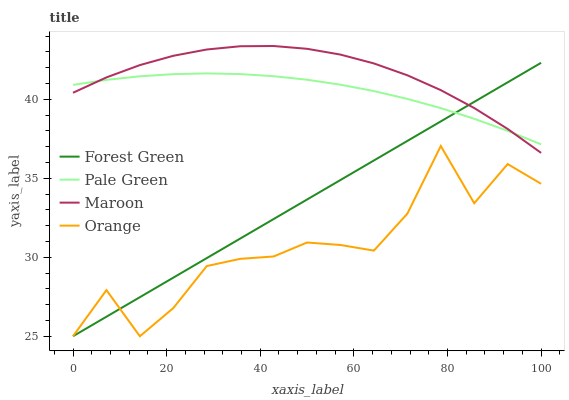Does Orange have the minimum area under the curve?
Answer yes or no. Yes. Does Maroon have the maximum area under the curve?
Answer yes or no. Yes. Does Forest Green have the minimum area under the curve?
Answer yes or no. No. Does Forest Green have the maximum area under the curve?
Answer yes or no. No. Is Forest Green the smoothest?
Answer yes or no. Yes. Is Orange the roughest?
Answer yes or no. Yes. Is Pale Green the smoothest?
Answer yes or no. No. Is Pale Green the roughest?
Answer yes or no. No. Does Orange have the lowest value?
Answer yes or no. Yes. Does Pale Green have the lowest value?
Answer yes or no. No. Does Maroon have the highest value?
Answer yes or no. Yes. Does Forest Green have the highest value?
Answer yes or no. No. Is Orange less than Maroon?
Answer yes or no. Yes. Is Maroon greater than Orange?
Answer yes or no. Yes. Does Maroon intersect Pale Green?
Answer yes or no. Yes. Is Maroon less than Pale Green?
Answer yes or no. No. Is Maroon greater than Pale Green?
Answer yes or no. No. Does Orange intersect Maroon?
Answer yes or no. No. 